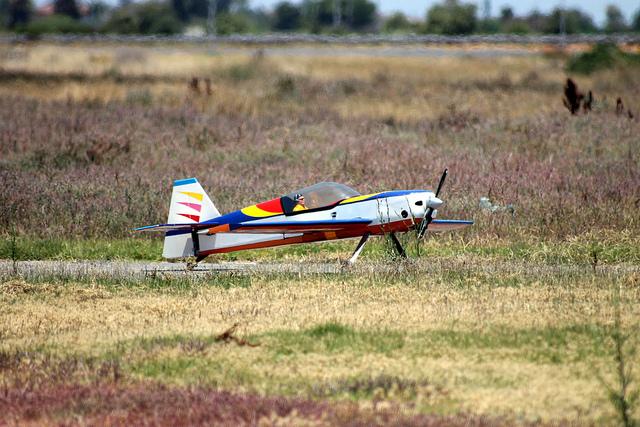What colors does the plane have?
Write a very short answer. Red, yellow, blue, brown, white. What is on the ground?
Keep it brief. Plane. Is this a single engine plane?
Concise answer only. Yes. 